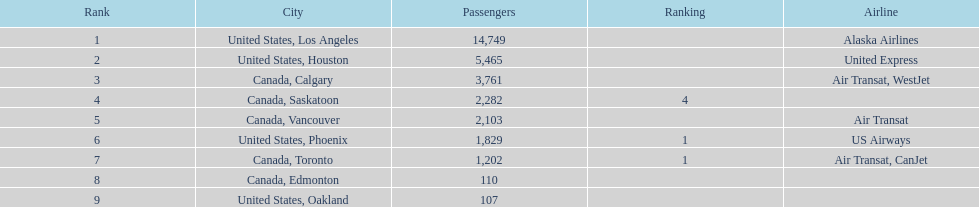What are all the cities? United States, Los Angeles, United States, Houston, Canada, Calgary, Canada, Saskatoon, Canada, Vancouver, United States, Phoenix, Canada, Toronto, Canada, Edmonton, United States, Oakland. How many passengers do they service? 14,749, 5,465, 3,761, 2,282, 2,103, 1,829, 1,202, 110, 107. Which city, when combined with los angeles, totals nearly 19,000? Canada, Calgary. 